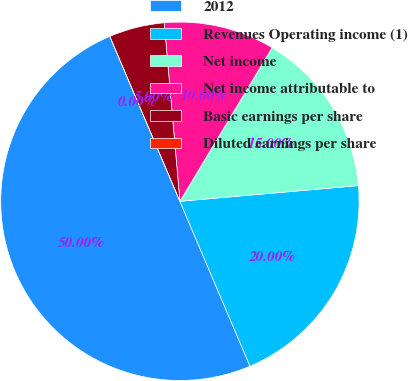<chart> <loc_0><loc_0><loc_500><loc_500><pie_chart><fcel>2012<fcel>Revenues Operating income (1)<fcel>Net income<fcel>Net income attributable to<fcel>Basic earnings per share<fcel>Diluted earnings per share<nl><fcel>50.0%<fcel>20.0%<fcel>15.0%<fcel>10.0%<fcel>5.0%<fcel>0.0%<nl></chart> 